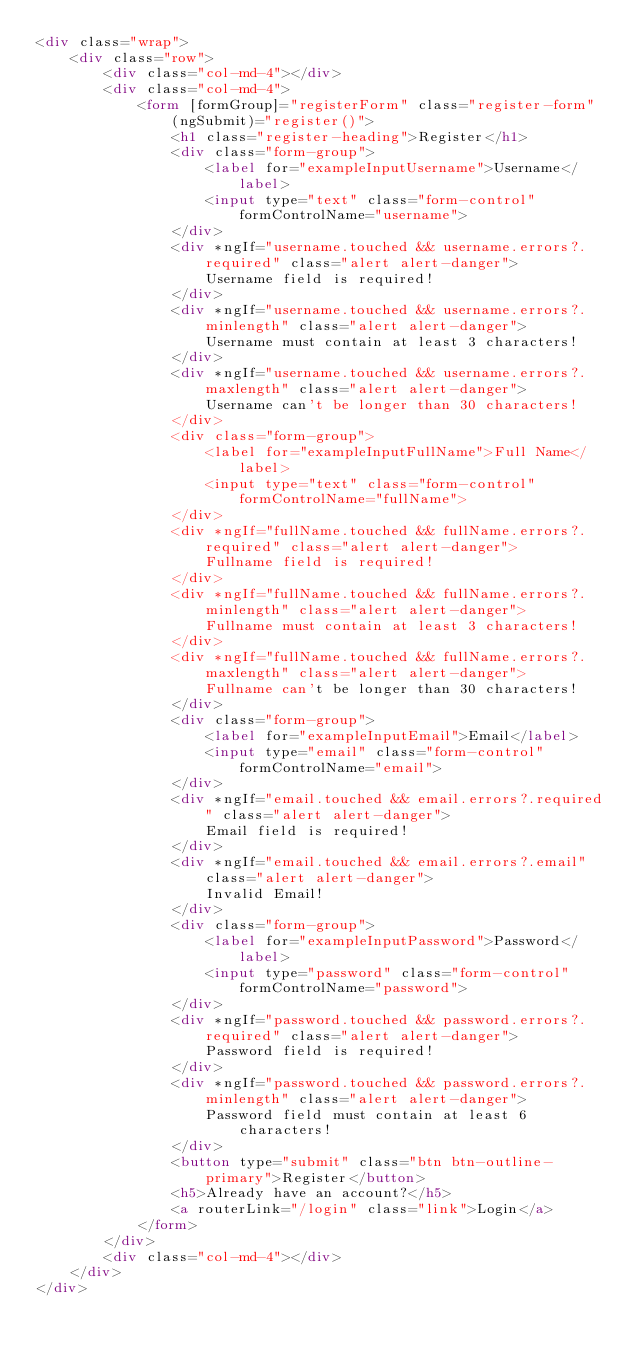Convert code to text. <code><loc_0><loc_0><loc_500><loc_500><_HTML_><div class="wrap">
    <div class="row">
        <div class="col-md-4"></div>
        <div class="col-md-4">
            <form [formGroup]="registerForm" class="register-form" (ngSubmit)="register()">
                <h1 class="register-heading">Register</h1>
                <div class="form-group">
                    <label for="exampleInputUsername">Username</label>
                    <input type="text" class="form-control" formControlName="username">
                </div>
                <div *ngIf="username.touched && username.errors?.required" class="alert alert-danger">
                    Username field is required!
                </div>
                <div *ngIf="username.touched && username.errors?.minlength" class="alert alert-danger">
                    Username must contain at least 3 characters!
                </div>
                <div *ngIf="username.touched && username.errors?.maxlength" class="alert alert-danger">
                    Username can't be longer than 30 characters!
                </div>
                <div class="form-group">
                    <label for="exampleInputFullName">Full Name</label>
                    <input type="text" class="form-control" formControlName="fullName">
                </div>
                <div *ngIf="fullName.touched && fullName.errors?.required" class="alert alert-danger">
                    Fullname field is required!
                </div>
                <div *ngIf="fullName.touched && fullName.errors?.minlength" class="alert alert-danger">
                    Fullname must contain at least 3 characters!
                </div>
                <div *ngIf="fullName.touched && fullName.errors?.maxlength" class="alert alert-danger">
                    Fullname can't be longer than 30 characters!
                </div>
                <div class="form-group">
                    <label for="exampleInputEmail">Email</label>
                    <input type="email" class="form-control" formControlName="email">
                </div>
                <div *ngIf="email.touched && email.errors?.required" class="alert alert-danger">
                    Email field is required!
                </div>
                <div *ngIf="email.touched && email.errors?.email" class="alert alert-danger">
                    Invalid Email!
                </div>
                <div class="form-group">
                    <label for="exampleInputPassword">Password</label>
                    <input type="password" class="form-control" formControlName="password">
                </div>
                <div *ngIf="password.touched && password.errors?.required" class="alert alert-danger">
                    Password field is required!
                </div>
                <div *ngIf="password.touched && password.errors?.minlength" class="alert alert-danger">
                    Password field must contain at least 6 characters!
                </div>
                <button type="submit" class="btn btn-outline-primary">Register</button>
                <h5>Already have an account?</h5> 
                <a routerLink="/login" class="link">Login</a>
            </form>
        </div>
        <div class="col-md-4"></div>
    </div>
</div></code> 